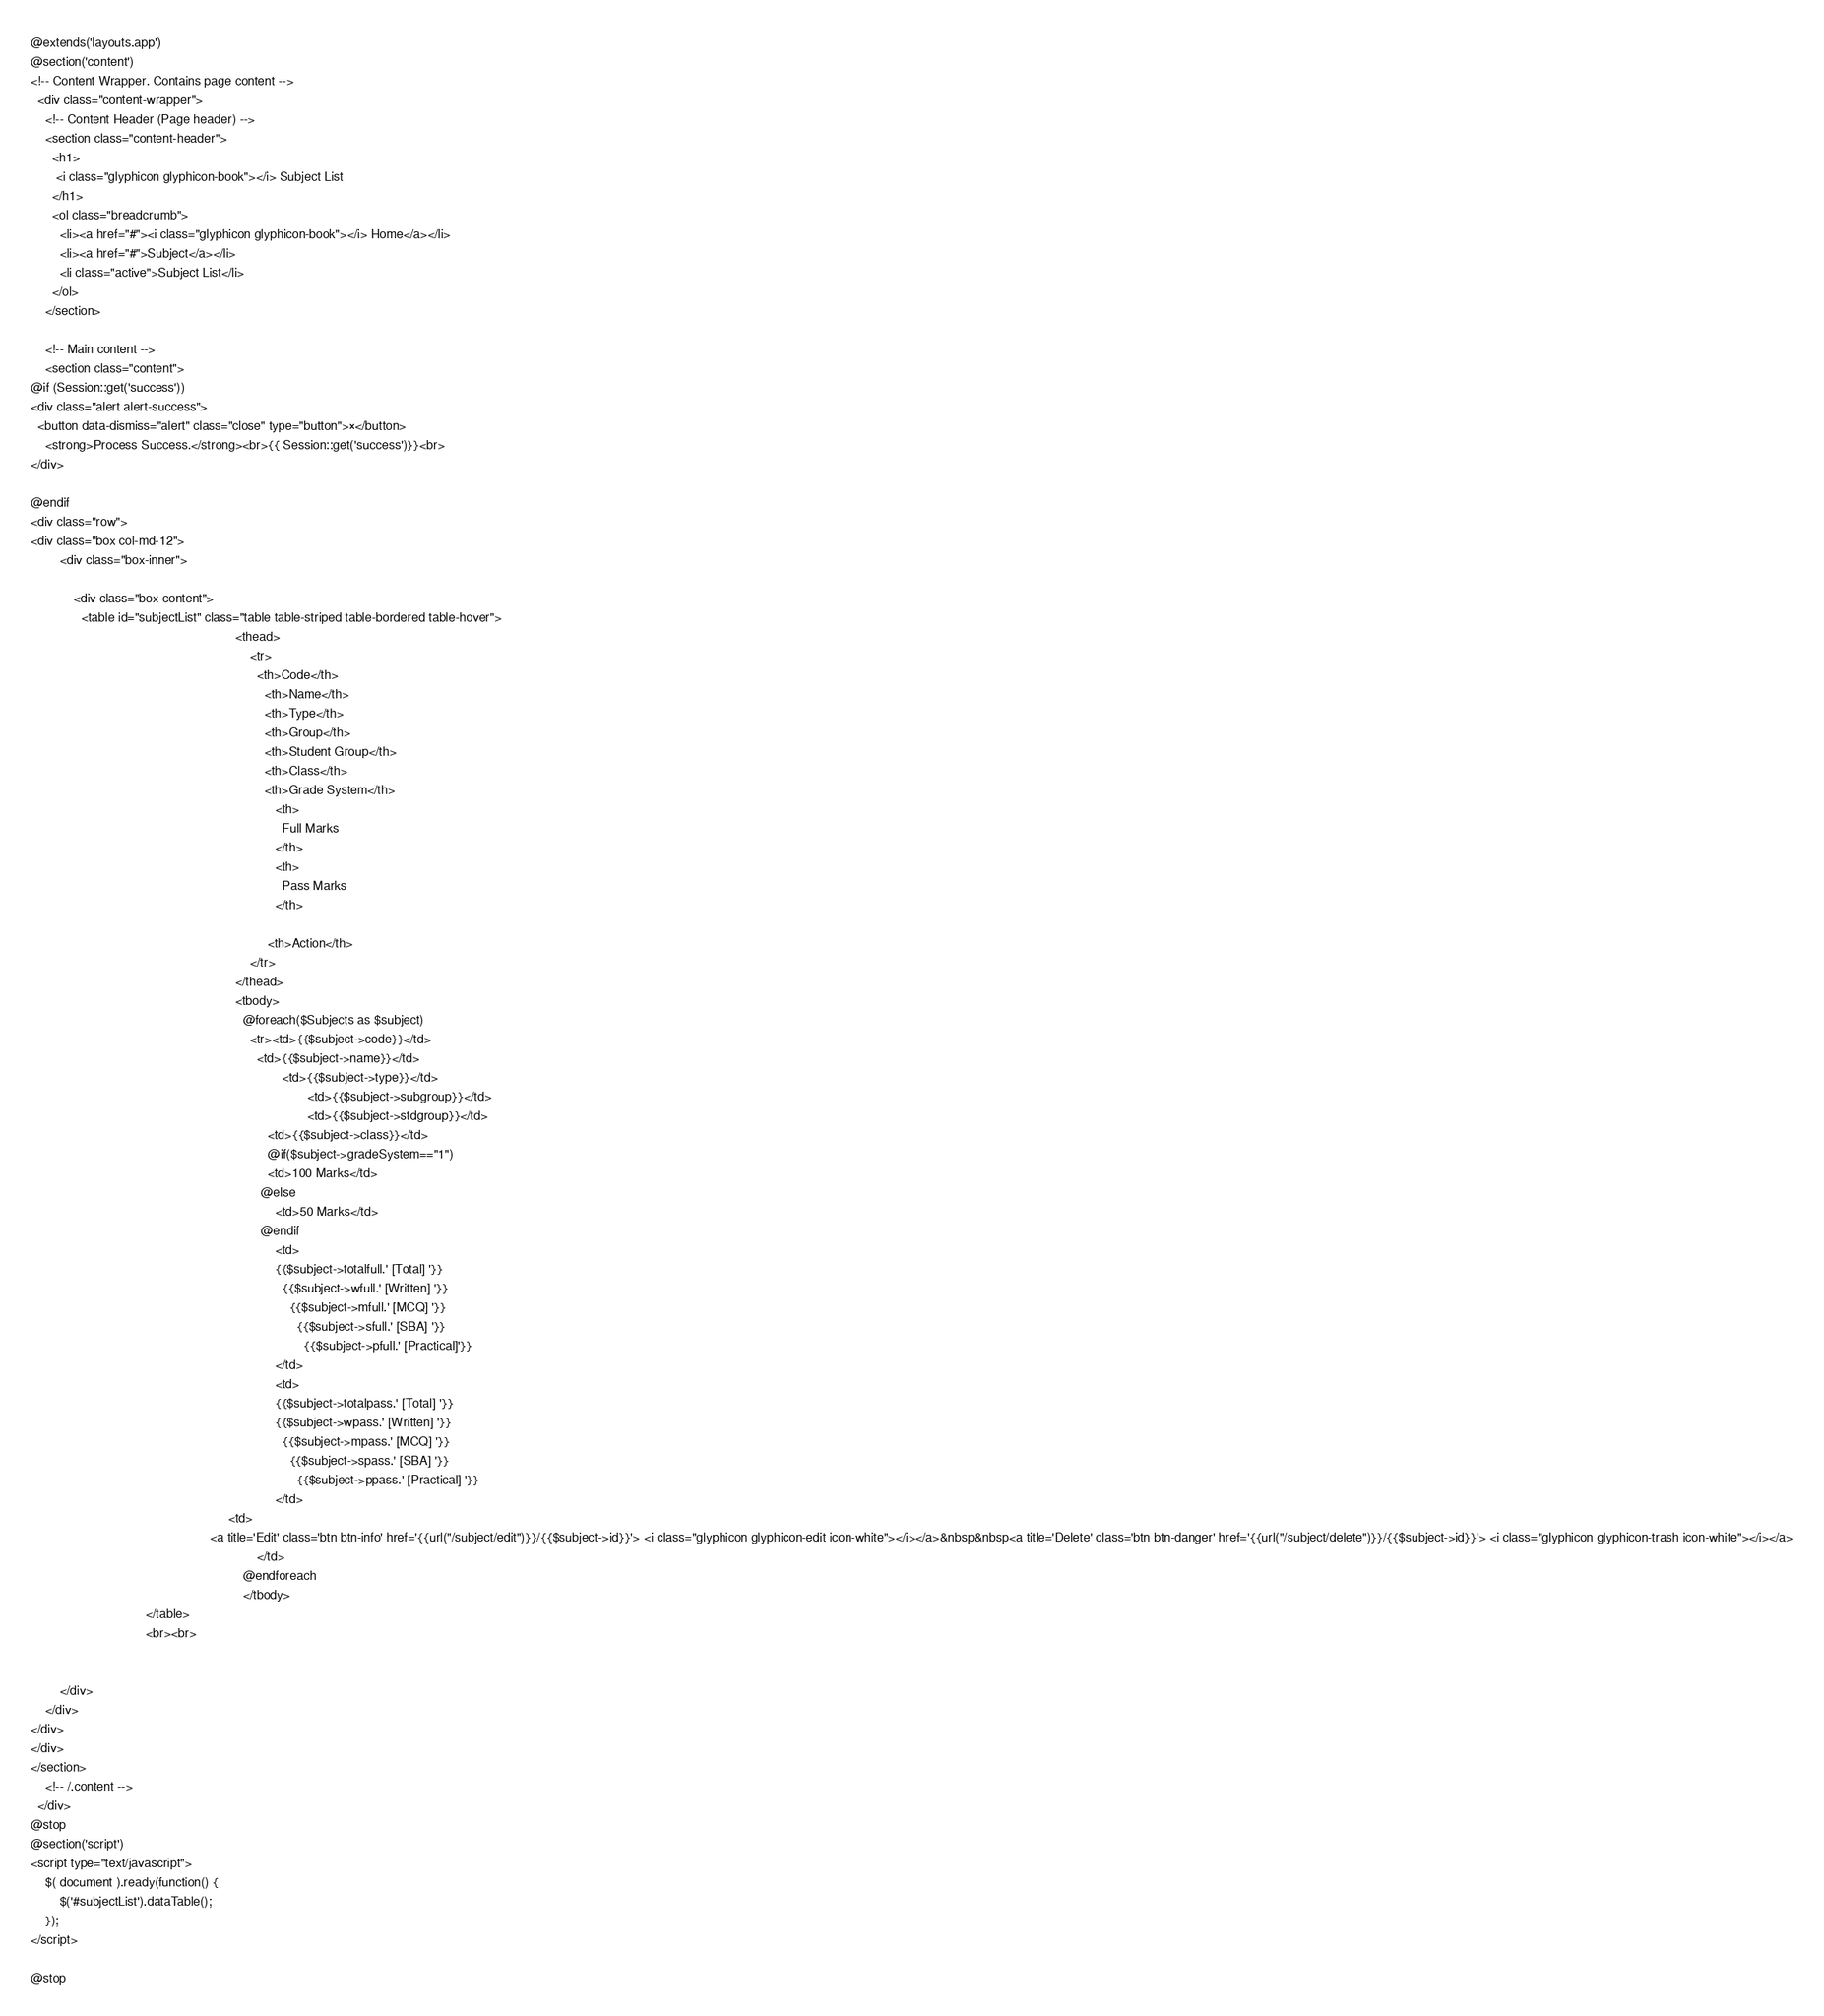Convert code to text. <code><loc_0><loc_0><loc_500><loc_500><_PHP_>@extends('layouts.app')
@section('content')
<!-- Content Wrapper. Contains page content -->
  <div class="content-wrapper">
    <!-- Content Header (Page header) -->
    <section class="content-header">
      <h1>
       <i class="glyphicon glyphicon-book"></i> Subject List
      </h1>
      <ol class="breadcrumb">
        <li><a href="#"><i class="glyphicon glyphicon-book"></i> Home</a></li>
        <li><a href="#">Subject</a></li>
        <li class="active">Subject List</li>
      </ol>
    </section>

    <!-- Main content -->
    <section class="content">
@if (Session::get('success'))
<div class="alert alert-success">
  <button data-dismiss="alert" class="close" type="button">×</button>
    <strong>Process Success.</strong><br>{{ Session::get('success')}}<br>
</div>

@endif
<div class="row">
<div class="box col-md-12">
        <div class="box-inner">
            
            <div class="box-content">
              <table id="subjectList" class="table table-striped table-bordered table-hover">
                                                         <thead>
                                                             <tr>
                                                               <th>Code</th>
                                                                 <th>Name</th>
                                                                 <th>Type</th>
                                                                 <th>Group</th>
                                                                 <th>Student Group</th>
                                                                 <th>Class</th>
                                                                 <th>Grade System</th>
                                                                    <th>
                                                                      Full Marks
                                                                    </th>
                                                                    <th>
                                                                      Pass Marks
                                                                    </th>

                                                                  <th>Action</th>
                                                             </tr>
                                                         </thead>
                                                         <tbody>
                                                           @foreach($Subjects as $subject)
                                                             <tr><td>{{$subject->code}}</td>
                                                               <td>{{$subject->name}}</td>
                                                                      <td>{{$subject->type}}</td>
                                                                             <td>{{$subject->subgroup}}</td>
                                                                             <td>{{$subject->stdgroup}}</td>
                                                                  <td>{{$subject->class}}</td>
                                                                  @if($subject->gradeSystem=="1")
                                                                  <td>100 Marks</td>
                                                                @else
                                                                    <td>50 Marks</td>
                                                                @endif
                                                                    <td>
                                                                    {{$subject->totalfull.' [Total] '}}
                                                                      {{$subject->wfull.' [Written] '}}
                                                                        {{$subject->mfull.' [MCQ] '}}
                                                                          {{$subject->sfull.' [SBA] '}}
                                                                            {{$subject->pfull.' [Practical]'}}
                                                                    </td>
                                                                    <td>
                                                                    {{$subject->totalpass.' [Total] '}}
                                                                    {{$subject->wpass.' [Written] '}}
                                                                      {{$subject->mpass.' [MCQ] '}}
                                                                        {{$subject->spass.' [SBA] '}}
                                                                          {{$subject->ppass.' [Practical] '}}
                                                                    </td>
                                                       <td>
                                                  <a title='Edit' class='btn btn-info' href='{{url("/subject/edit")}}/{{$subject->id}}'> <i class="glyphicon glyphicon-edit icon-white"></i></a>&nbsp&nbsp<a title='Delete' class='btn btn-danger' href='{{url("/subject/delete")}}/{{$subject->id}}'> <i class="glyphicon glyphicon-trash icon-white"></i></a>
                                                               </td>
                                                           @endforeach
                                                           </tbody>
                                </table>
                                <br><br>


        </div>
    </div>
</div>
</div>
</section>
    <!-- /.content -->
  </div>
@stop
@section('script')
<script type="text/javascript">
    $( document ).ready(function() {
        $('#subjectList').dataTable();
    });
</script>
  
@stop
</code> 